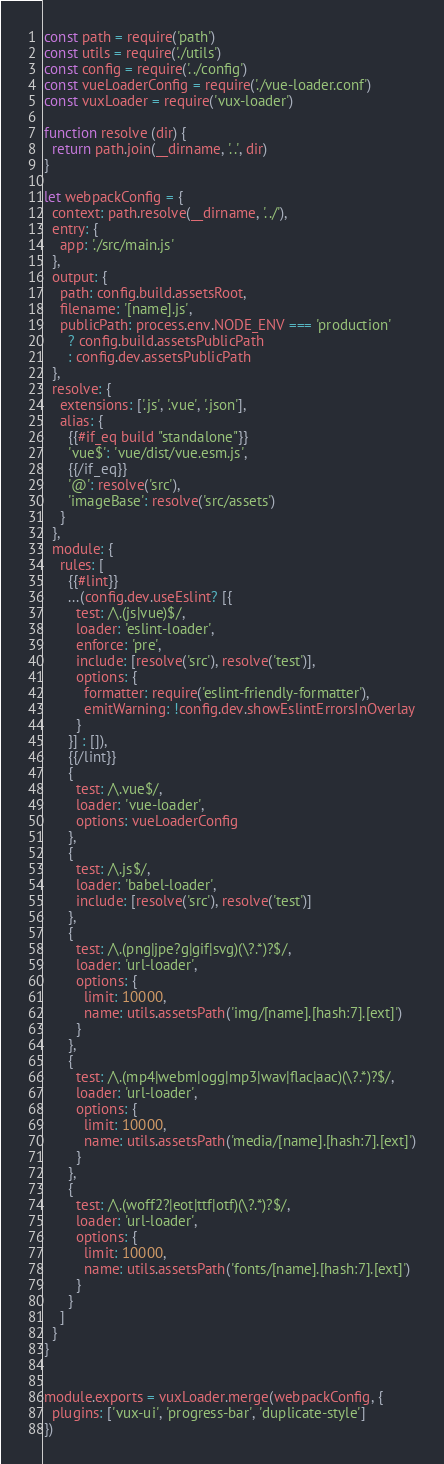Convert code to text. <code><loc_0><loc_0><loc_500><loc_500><_JavaScript_>const path = require('path')
const utils = require('./utils')
const config = require('../config')
const vueLoaderConfig = require('./vue-loader.conf')
const vuxLoader = require('vux-loader')

function resolve (dir) {
  return path.join(__dirname, '..', dir)
}

let webpackConfig = {
  context: path.resolve(__dirname, '../'),
  entry: {
    app: './src/main.js'
  },
  output: {
    path: config.build.assetsRoot,
    filename: '[name].js',
    publicPath: process.env.NODE_ENV === 'production'
      ? config.build.assetsPublicPath
      : config.dev.assetsPublicPath
  },
  resolve: {
    extensions: ['.js', '.vue', '.json'],
    alias: {
      {{#if_eq build "standalone"}}
      'vue$': 'vue/dist/vue.esm.js',
      {{/if_eq}}
      '@': resolve('src'),
      'imageBase': resolve('src/assets')
    }
  },
  module: {
    rules: [
      {{#lint}}
      ...(config.dev.useEslint? [{
        test: /\.(js|vue)$/,
        loader: 'eslint-loader',
        enforce: 'pre',
        include: [resolve('src'), resolve('test')],
        options: {
          formatter: require('eslint-friendly-formatter'),
          emitWarning: !config.dev.showEslintErrorsInOverlay
        }
      }] : []),
      {{/lint}}
      {
        test: /\.vue$/,
        loader: 'vue-loader',
        options: vueLoaderConfig
      },
      {
        test: /\.js$/,
        loader: 'babel-loader',
        include: [resolve('src'), resolve('test')]
      },
      {
        test: /\.(png|jpe?g|gif|svg)(\?.*)?$/,
        loader: 'url-loader',
        options: {
          limit: 10000,
          name: utils.assetsPath('img/[name].[hash:7].[ext]')
        }
      },
      {
        test: /\.(mp4|webm|ogg|mp3|wav|flac|aac)(\?.*)?$/,
        loader: 'url-loader',
        options: {
          limit: 10000,
          name: utils.assetsPath('media/[name].[hash:7].[ext]')
        }
      },
      {
        test: /\.(woff2?|eot|ttf|otf)(\?.*)?$/,
        loader: 'url-loader',
        options: {
          limit: 10000,
          name: utils.assetsPath('fonts/[name].[hash:7].[ext]')
        }
      }
    ]
  }
}


module.exports = vuxLoader.merge(webpackConfig, {
  plugins: ['vux-ui', 'progress-bar', 'duplicate-style']
})
</code> 